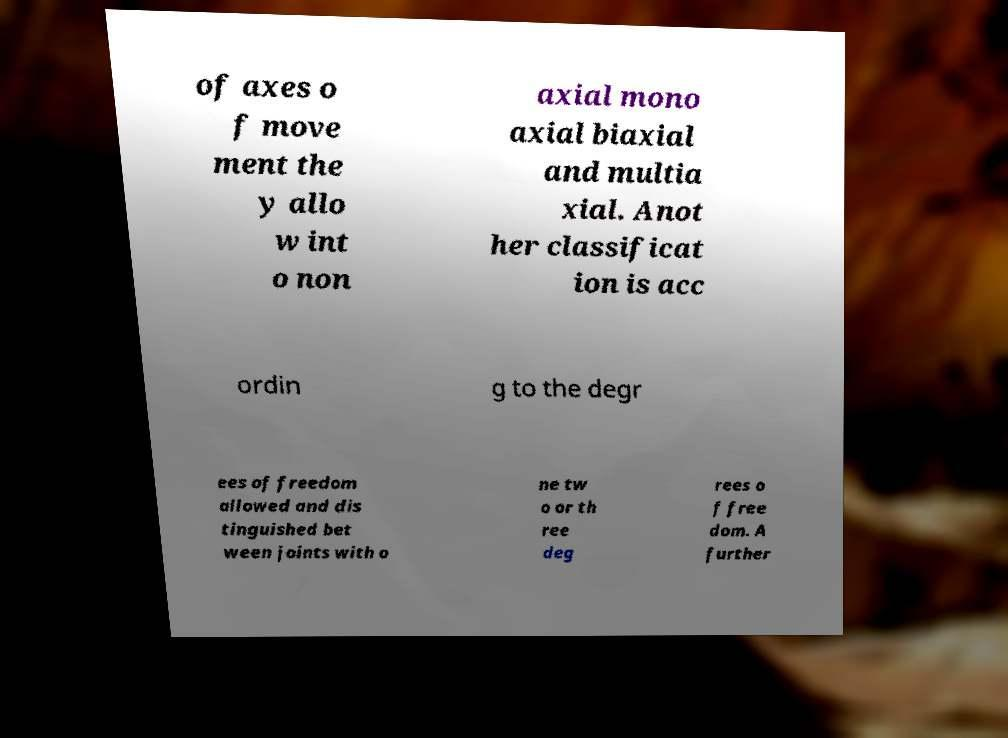I need the written content from this picture converted into text. Can you do that? of axes o f move ment the y allo w int o non axial mono axial biaxial and multia xial. Anot her classificat ion is acc ordin g to the degr ees of freedom allowed and dis tinguished bet ween joints with o ne tw o or th ree deg rees o f free dom. A further 